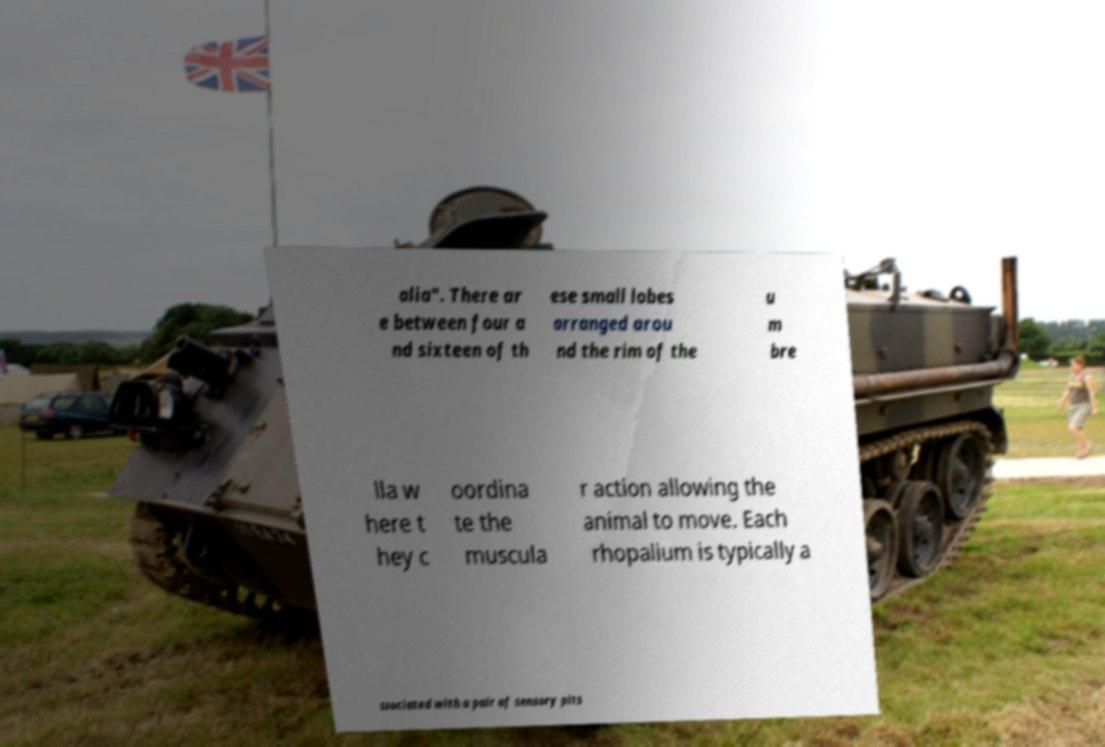Could you extract and type out the text from this image? alia". There ar e between four a nd sixteen of th ese small lobes arranged arou nd the rim of the u m bre lla w here t hey c oordina te the muscula r action allowing the animal to move. Each rhopalium is typically a ssociated with a pair of sensory pits 